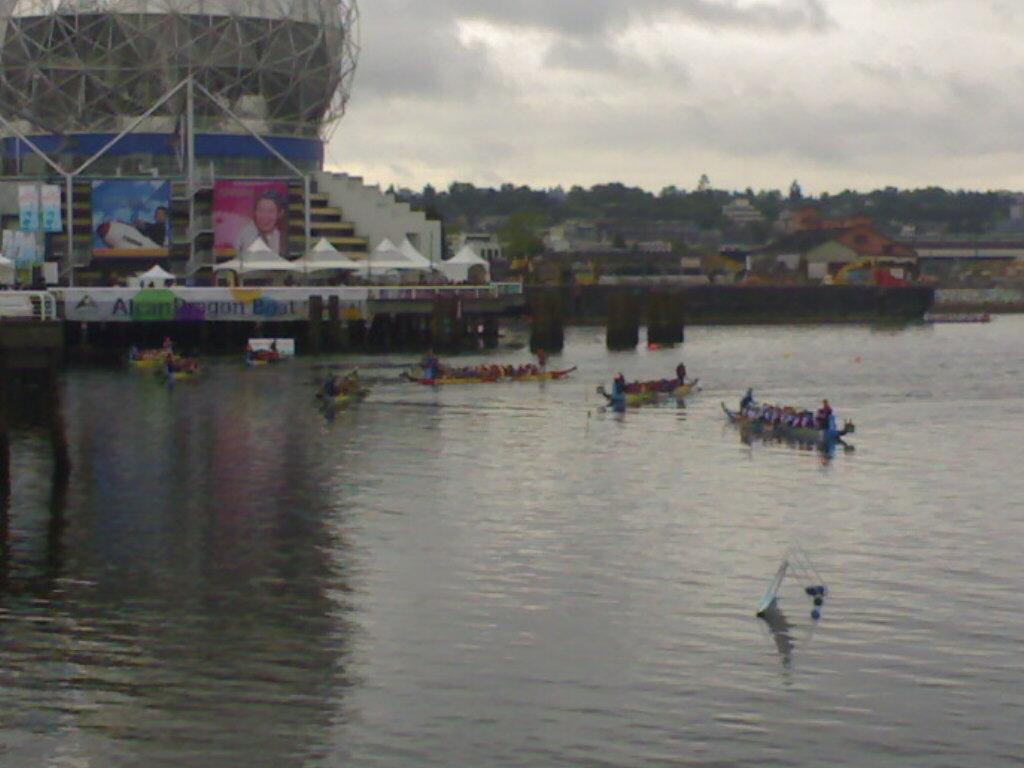Describe this image in one or two sentences. In this image we can see a group of people in some boats which are in the water. On the backside we can see a bridge with some pillars, a board with some text on it, some tents, a building with some poles, boards with some pictures on it, a group of buildings, trees and the sky which looks cloudy. 